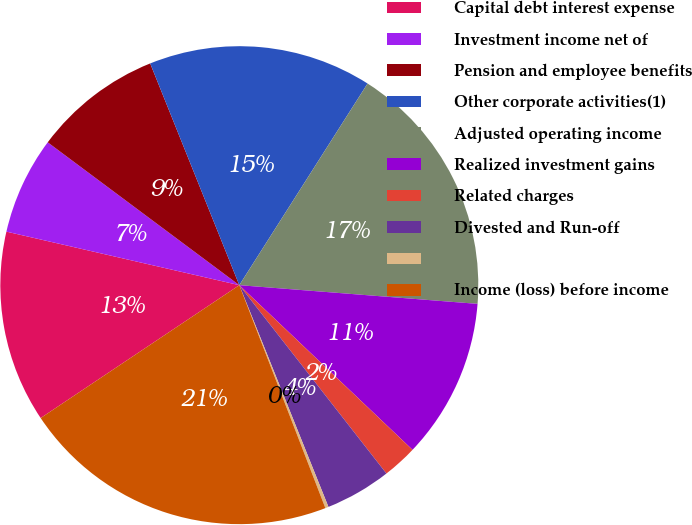Convert chart to OTSL. <chart><loc_0><loc_0><loc_500><loc_500><pie_chart><fcel>Capital debt interest expense<fcel>Investment income net of<fcel>Pension and employee benefits<fcel>Other corporate activities(1)<fcel>Adjusted operating income<fcel>Realized investment gains<fcel>Related charges<fcel>Divested and Run-off<fcel>Unnamed: 8<fcel>Income (loss) before income<nl><fcel>12.98%<fcel>6.6%<fcel>8.72%<fcel>15.1%<fcel>17.23%<fcel>10.85%<fcel>2.35%<fcel>4.47%<fcel>0.22%<fcel>21.48%<nl></chart> 